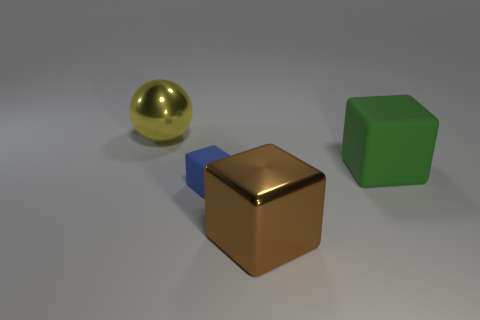What material is the large object that is on the left side of the large metallic thing in front of the blue cube made of? The large object on the left side of the metallic entity in front of the blue cube appears to be a sphere made of a shiny material, likely a polished metal such as brass or gold, giving it a reflective golden surface that stands out against the more muted tones in the image. 